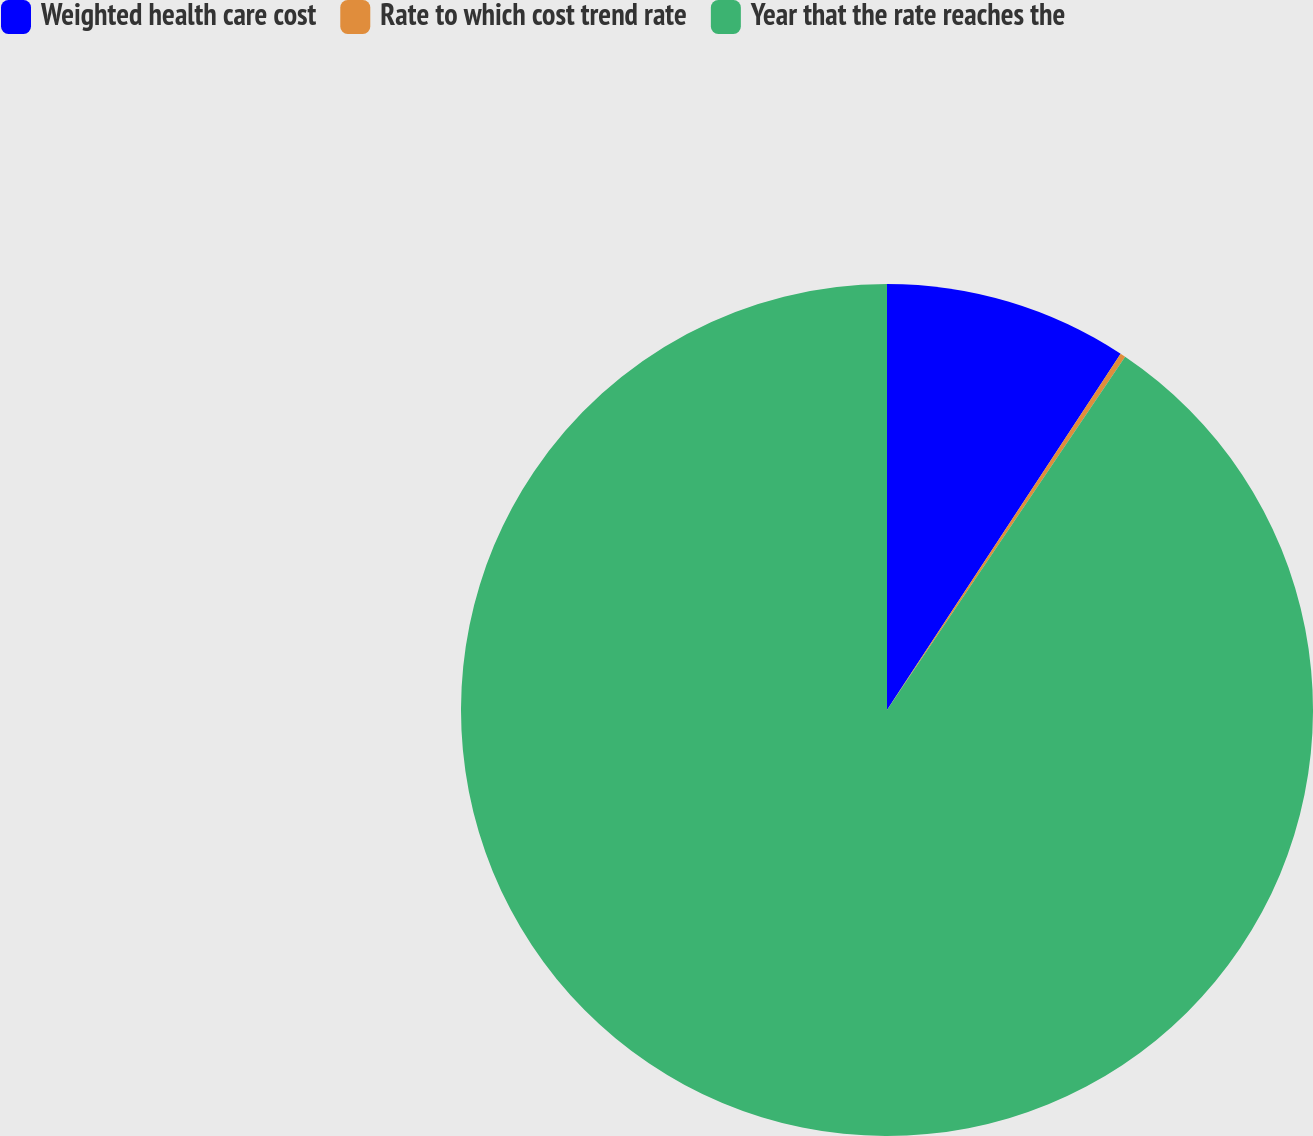Convert chart. <chart><loc_0><loc_0><loc_500><loc_500><pie_chart><fcel>Weighted health care cost<fcel>Rate to which cost trend rate<fcel>Year that the rate reaches the<nl><fcel>9.24%<fcel>0.2%<fcel>90.56%<nl></chart> 